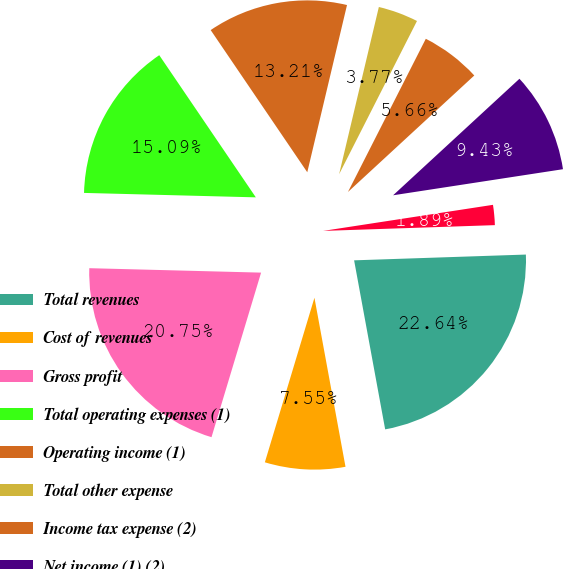Convert chart to OTSL. <chart><loc_0><loc_0><loc_500><loc_500><pie_chart><fcel>Total revenues<fcel>Cost of revenues<fcel>Gross profit<fcel>Total operating expenses (1)<fcel>Operating income (1)<fcel>Total other expense<fcel>Income tax expense (2)<fcel>Net income (1) (2)<fcel>Net income applicable to<nl><fcel>22.64%<fcel>7.55%<fcel>20.75%<fcel>15.09%<fcel>13.21%<fcel>3.77%<fcel>5.66%<fcel>9.43%<fcel>1.89%<nl></chart> 